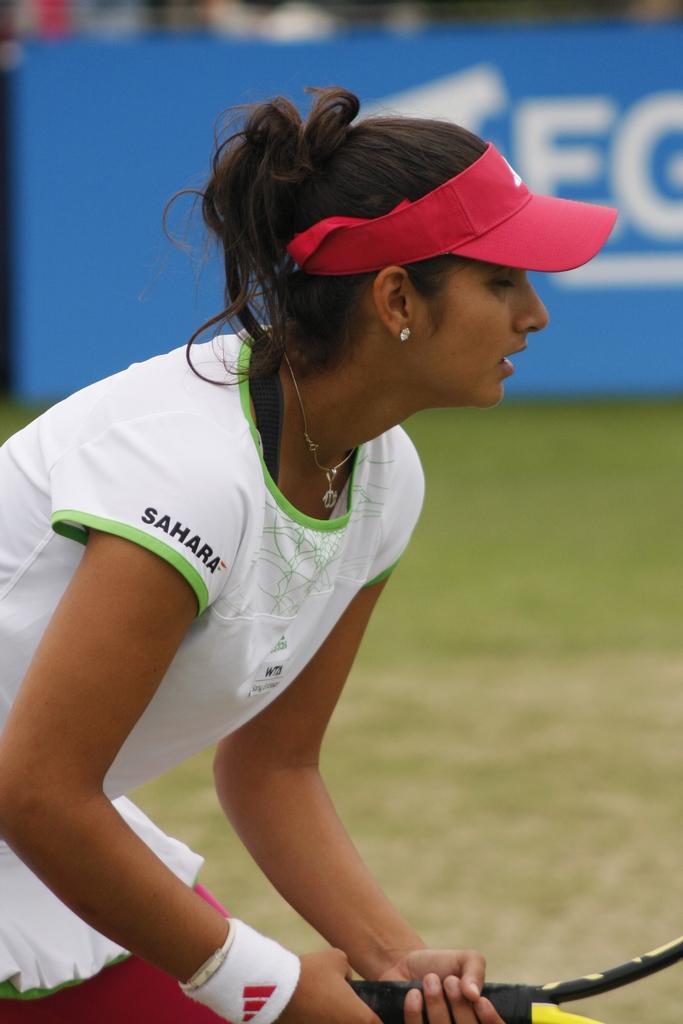In one or two sentences, can you explain what this image depicts? In this picture we can see a woman standing and holding a tennis bat, in the bottom we can see grass, in the background there is a hoarding, the woman wore a cap. 